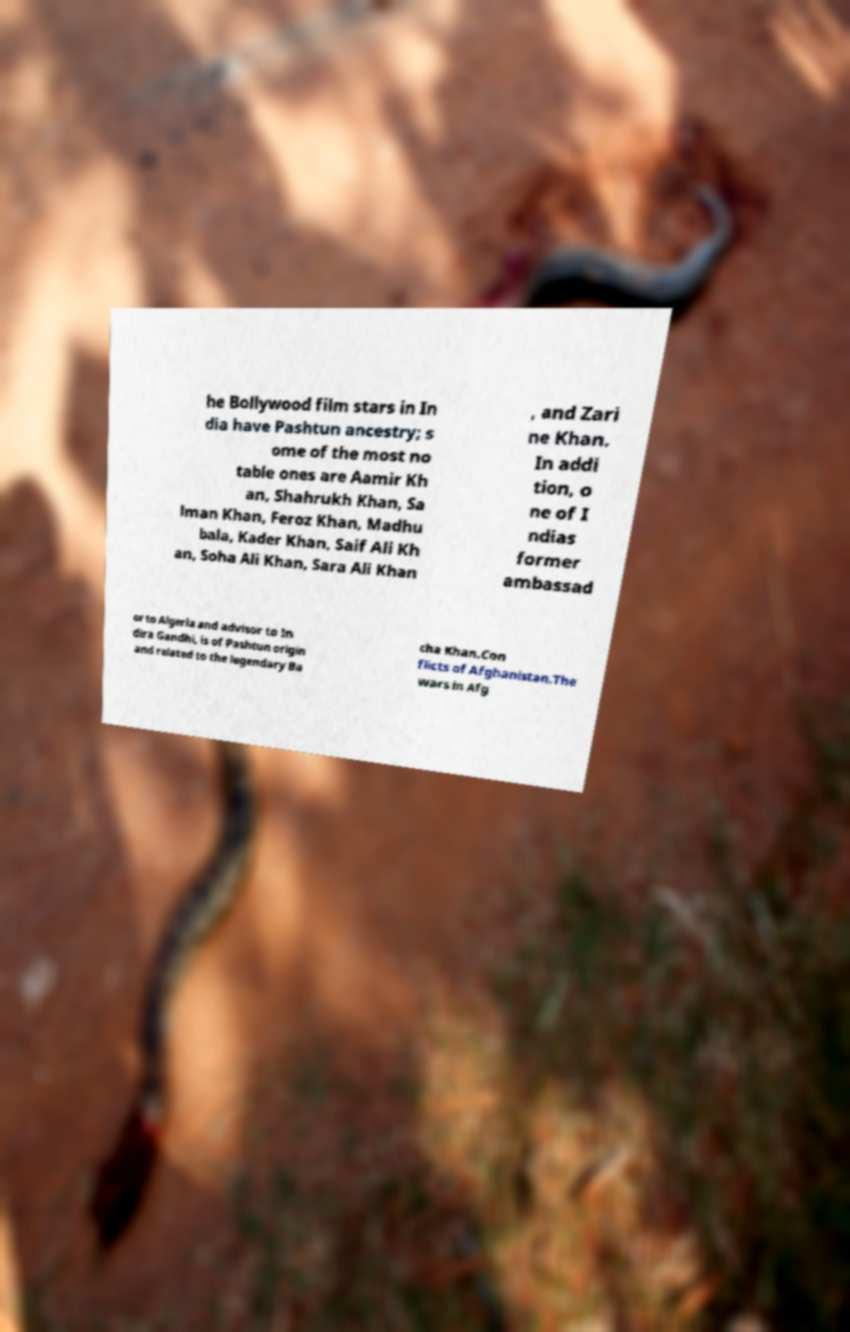Could you extract and type out the text from this image? he Bollywood film stars in In dia have Pashtun ancestry; s ome of the most no table ones are Aamir Kh an, Shahrukh Khan, Sa lman Khan, Feroz Khan, Madhu bala, Kader Khan, Saif Ali Kh an, Soha Ali Khan, Sara Ali Khan , and Zari ne Khan. In addi tion, o ne of I ndias former ambassad or to Algeria and advisor to In dira Gandhi, is of Pashtun origin and related to the legendary Ba cha Khan.Con flicts of Afghanistan.The wars in Afg 